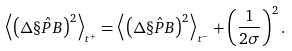Convert formula to latex. <formula><loc_0><loc_0><loc_500><loc_500>\left \langle \left ( \Delta \hat { \S P B } \right ) ^ { 2 } \right \rangle _ { t ^ { + } } = \left \langle \left ( \Delta \hat { \S P B } \right ) ^ { 2 } \right \rangle _ { t ^ { - } } + \left ( \frac { 1 } { 2 \sigma } \right ) ^ { 2 } .</formula> 